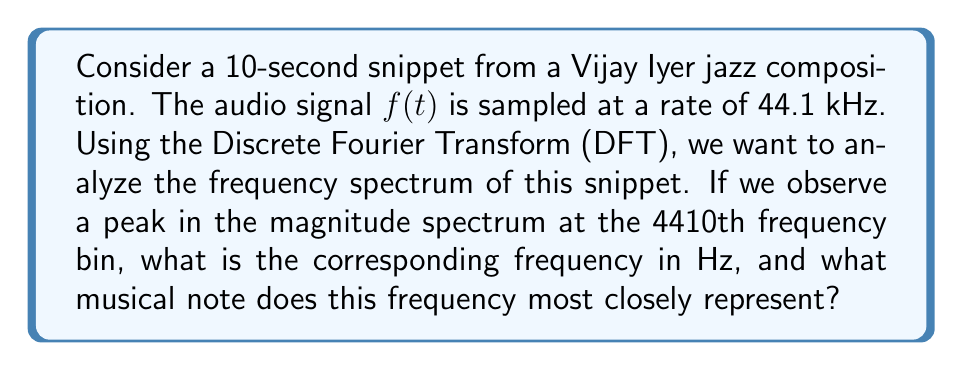Solve this math problem. To solve this problem, we need to follow these steps:

1) First, let's calculate the frequency resolution of our DFT. The frequency resolution is given by:

   $$\Delta f = \frac{f_s}{N}$$

   where $f_s$ is the sampling frequency and $N$ is the total number of samples.

2) We know $f_s = 44100$ Hz. To find $N$, we multiply the duration by the sampling rate:

   $$N = 10 \text{ seconds} \times 44100 \text{ Hz} = 441000 \text{ samples}$$

3) Now we can calculate $\Delta f$:

   $$\Delta f = \frac{44100 \text{ Hz}}{441000} = 0.1 \text{ Hz}$$

4) The frequency corresponding to the $k$th bin is given by $k \times \Delta f$. Here, $k = 4410$, so:

   $$f = 4410 \times 0.1 \text{ Hz} = 441 \text{ Hz}$$

5) To determine the musical note, we can compare this to standard note frequencies. The closest standard note to 441 Hz is A4, which has a frequency of 440 Hz.
Answer: The frequency corresponding to the 4410th bin is 441 Hz, which most closely represents the musical note A4. 